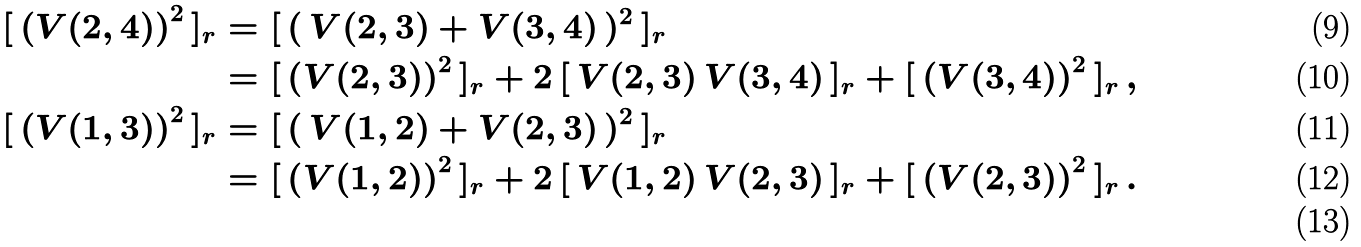<formula> <loc_0><loc_0><loc_500><loc_500>[ \, \left ( V ( 2 , 4 ) \right ) ^ { 2 } \, ] _ { r } & = [ \, ( \, V ( 2 , 3 ) + V ( 3 , 4 ) \, ) ^ { 2 } \, ] _ { r } \\ & = [ \, \left ( V ( 2 , 3 ) \right ) ^ { 2 } \, ] _ { r } + 2 \, [ \, V ( 2 , 3 ) \, V ( 3 , 4 ) \, ] _ { r } + [ \, \left ( V ( 3 , 4 ) \right ) ^ { 2 } \, ] _ { r } \, , \\ [ \, \left ( V ( 1 , 3 ) \right ) ^ { 2 } \, ] _ { r } & = [ \, ( \, V ( 1 , 2 ) + V ( 2 , 3 ) \, ) ^ { 2 } \, ] _ { r } \\ & = [ \, \left ( V ( 1 , 2 ) \right ) ^ { 2 } \, ] _ { r } + 2 \, [ \, V ( 1 , 2 ) \, V ( 2 , 3 ) \, ] _ { r } + [ \, \left ( V ( 2 , 3 ) \right ) ^ { 2 } \, ] _ { r } \, . \\</formula> 